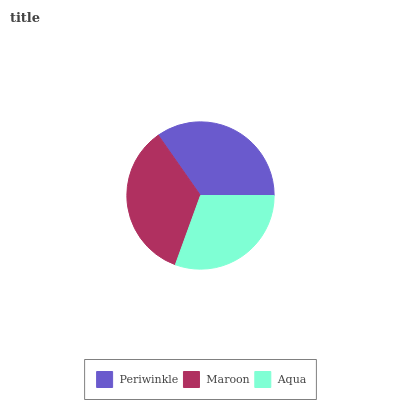Is Aqua the minimum?
Answer yes or no. Yes. Is Maroon the maximum?
Answer yes or no. Yes. Is Maroon the minimum?
Answer yes or no. No. Is Aqua the maximum?
Answer yes or no. No. Is Maroon greater than Aqua?
Answer yes or no. Yes. Is Aqua less than Maroon?
Answer yes or no. Yes. Is Aqua greater than Maroon?
Answer yes or no. No. Is Maroon less than Aqua?
Answer yes or no. No. Is Periwinkle the high median?
Answer yes or no. Yes. Is Periwinkle the low median?
Answer yes or no. Yes. Is Aqua the high median?
Answer yes or no. No. Is Maroon the low median?
Answer yes or no. No. 